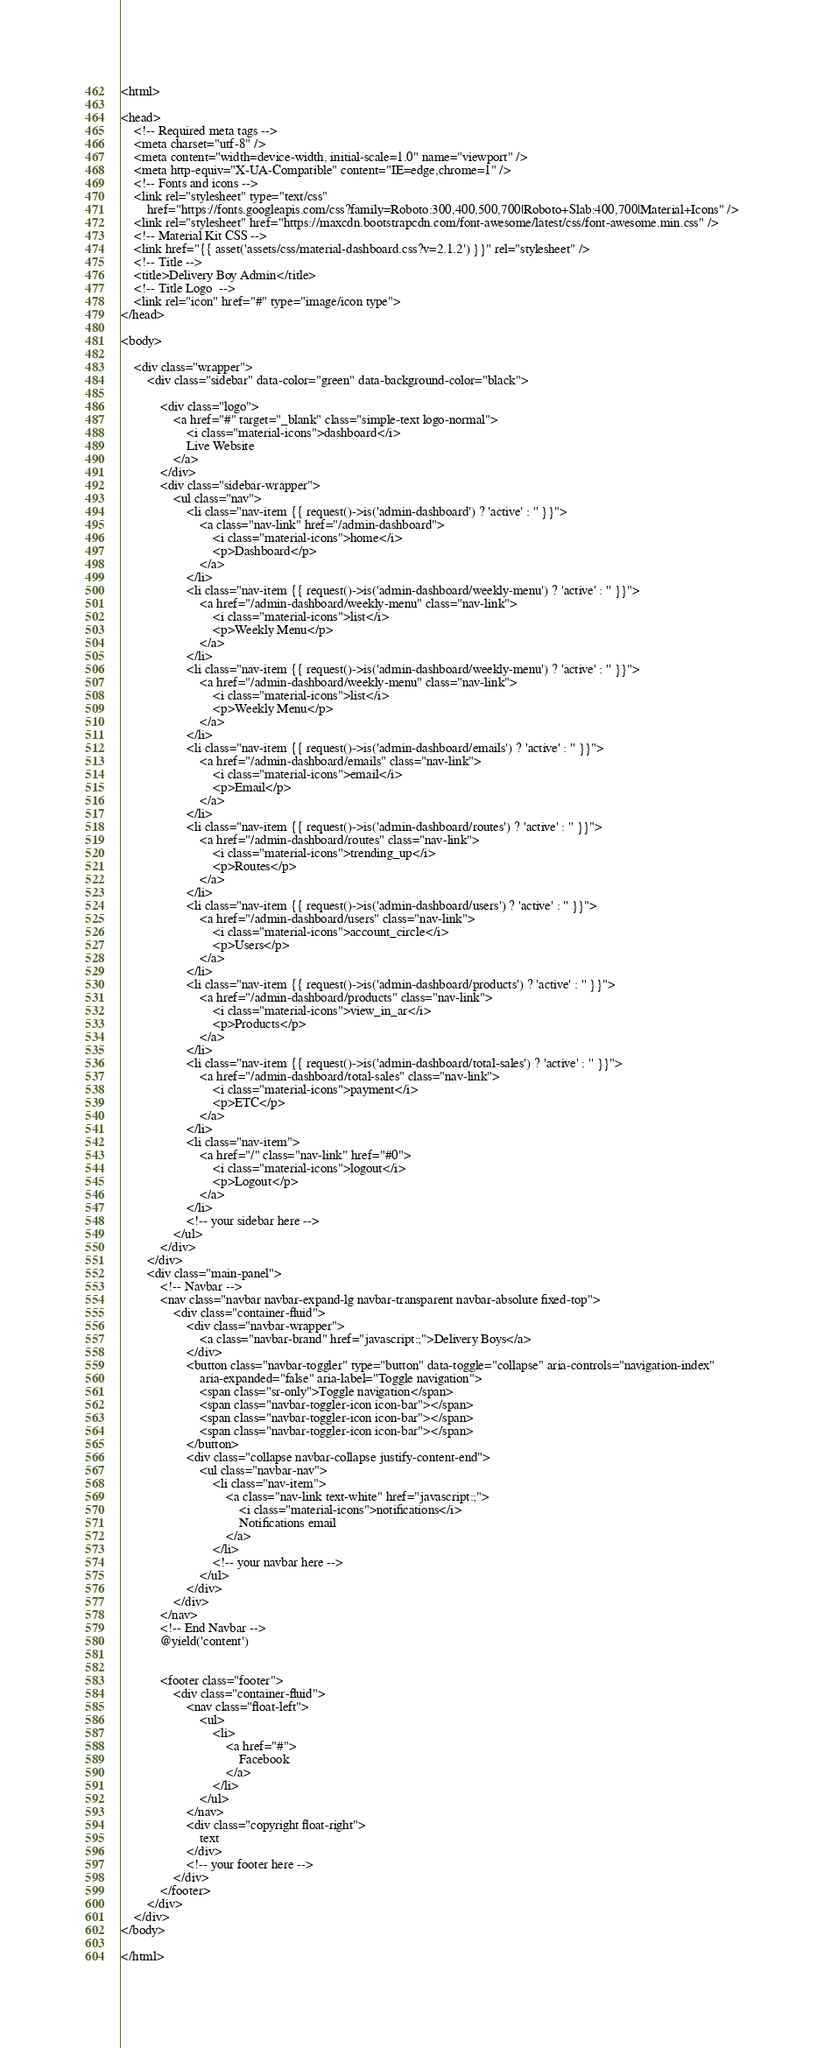<code> <loc_0><loc_0><loc_500><loc_500><_PHP_><html>

<head>
    <!-- Required meta tags -->
    <meta charset="utf-8" />
    <meta content="width=device-width, initial-scale=1.0" name="viewport" />
    <meta http-equiv="X-UA-Compatible" content="IE=edge,chrome=1" />
    <!-- Fonts and icons -->
    <link rel="stylesheet" type="text/css"
        href="https://fonts.googleapis.com/css?family=Roboto:300,400,500,700|Roboto+Slab:400,700|Material+Icons" />
    <link rel="stylesheet" href="https://maxcdn.bootstrapcdn.com/font-awesome/latest/css/font-awesome.min.css" />
    <!-- Material Kit CSS -->
    <link href="{{ asset('assets/css/material-dashboard.css?v=2.1.2') }}" rel="stylesheet" />
    <!-- Title -->
    <title>Delivery Boy Admin</title>
    <!-- Title Logo  -->
    <link rel="icon" href="#" type="image/icon type">
</head>

<body>

    <div class="wrapper">
        <div class="sidebar" data-color="green" data-background-color="black">

            <div class="logo">
                <a href="#" target="_blank" class="simple-text logo-normal">
                    <i class="material-icons">dashboard</i>
                    Live Website
                </a>
            </div>
            <div class="sidebar-wrapper">
                <ul class="nav">
                    <li class="nav-item {{ request()->is('admin-dashboard') ? 'active' : '' }}">
                        <a class="nav-link" href="/admin-dashboard">
                            <i class="material-icons">home</i>
                            <p>Dashboard</p>
                        </a>
                    </li>
                    <li class="nav-item {{ request()->is('admin-dashboard/weekly-menu') ? 'active' : '' }}">
                        <a href="/admin-dashboard/weekly-menu" class="nav-link">
                            <i class="material-icons">list</i>
                            <p>Weekly Menu</p>
                        </a>
                    </li>
                    <li class="nav-item {{ request()->is('admin-dashboard/weekly-menu') ? 'active' : '' }}">
                        <a href="/admin-dashboard/weekly-menu" class="nav-link">
                            <i class="material-icons">list</i>
                            <p>Weekly Menu</p>
                        </a>
                    </li>
                    <li class="nav-item {{ request()->is('admin-dashboard/emails') ? 'active' : '' }}">
                        <a href="/admin-dashboard/emails" class="nav-link">
                            <i class="material-icons">email</i>
                            <p>Email</p>
                        </a>
                    </li>
                    <li class="nav-item {{ request()->is('admin-dashboard/routes') ? 'active' : '' }}">
                        <a href="/admin-dashboard/routes" class="nav-link">
                            <i class="material-icons">trending_up</i>
                            <p>Routes</p>
                        </a>
                    </li>
                    <li class="nav-item {{ request()->is('admin-dashboard/users') ? 'active' : '' }}">
                        <a href="/admin-dashboard/users" class="nav-link">
                            <i class="material-icons">account_circle</i>
                            <p>Users</p>
                        </a>
                    </li>
                    <li class="nav-item {{ request()->is('admin-dashboard/products') ? 'active' : '' }}">
                        <a href="/admin-dashboard/products" class="nav-link">
                            <i class="material-icons">view_in_ar</i>
                            <p>Products</p>
                        </a>
                    </li>
                    <li class="nav-item {{ request()->is('admin-dashboard/total-sales') ? 'active' : '' }}">
                        <a href="/admin-dashboard/total-sales" class="nav-link">
                            <i class="material-icons">payment</i>
                            <p>ETC</p>
                        </a>
                    </li>
                    <li class="nav-item">
                        <a href="/" class="nav-link" href="#0">
                            <i class="material-icons">logout</i>
                            <p>Logout</p>
                        </a>
                    </li>
                    <!-- your sidebar here -->
                </ul>
            </div>
        </div>
        <div class="main-panel">
            <!-- Navbar -->
            <nav class="navbar navbar-expand-lg navbar-transparent navbar-absolute fixed-top">
                <div class="container-fluid">
                    <div class="navbar-wrapper">
                        <a class="navbar-brand" href="javascript:;">Delivery Boys</a>
                    </div>
                    <button class="navbar-toggler" type="button" data-toggle="collapse" aria-controls="navigation-index"
                        aria-expanded="false" aria-label="Toggle navigation">
                        <span class="sr-only">Toggle navigation</span>
                        <span class="navbar-toggler-icon icon-bar"></span>
                        <span class="navbar-toggler-icon icon-bar"></span>
                        <span class="navbar-toggler-icon icon-bar"></span>
                    </button>
                    <div class="collapse navbar-collapse justify-content-end">
                        <ul class="navbar-nav">
                            <li class="nav-item">
                                <a class="nav-link text-white" href="javascript:;">
                                    <i class="material-icons">notifications</i>
                                    Notifications email
                                </a>
                            </li>
                            <!-- your navbar here -->
                        </ul>
                    </div>
                </div>
            </nav>
            <!-- End Navbar -->
            @yield('content')


            <footer class="footer">
                <div class="container-fluid">
                    <nav class="float-left">
                        <ul>
                            <li>
                                <a href="#">
                                    Facebook
                                </a>
                            </li>
                        </ul>
                    </nav>
                    <div class="copyright float-right">
                        text
                    </div>
                    <!-- your footer here -->
                </div>
            </footer>
        </div>
    </div>
</body>

</html></code> 